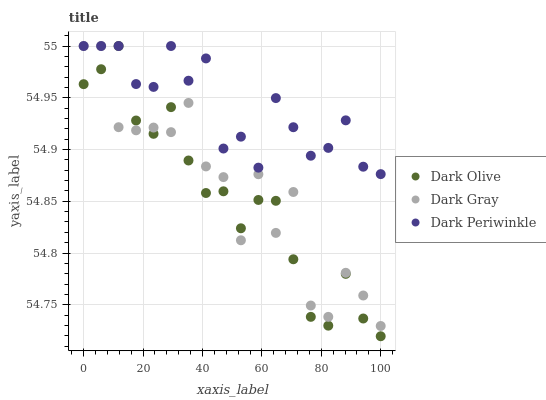Does Dark Olive have the minimum area under the curve?
Answer yes or no. Yes. Does Dark Periwinkle have the maximum area under the curve?
Answer yes or no. Yes. Does Dark Periwinkle have the minimum area under the curve?
Answer yes or no. No. Does Dark Olive have the maximum area under the curve?
Answer yes or no. No. Is Dark Olive the smoothest?
Answer yes or no. Yes. Is Dark Gray the roughest?
Answer yes or no. Yes. Is Dark Periwinkle the smoothest?
Answer yes or no. No. Is Dark Periwinkle the roughest?
Answer yes or no. No. Does Dark Olive have the lowest value?
Answer yes or no. Yes. Does Dark Periwinkle have the lowest value?
Answer yes or no. No. Does Dark Periwinkle have the highest value?
Answer yes or no. Yes. Does Dark Olive intersect Dark Periwinkle?
Answer yes or no. Yes. Is Dark Olive less than Dark Periwinkle?
Answer yes or no. No. Is Dark Olive greater than Dark Periwinkle?
Answer yes or no. No. 